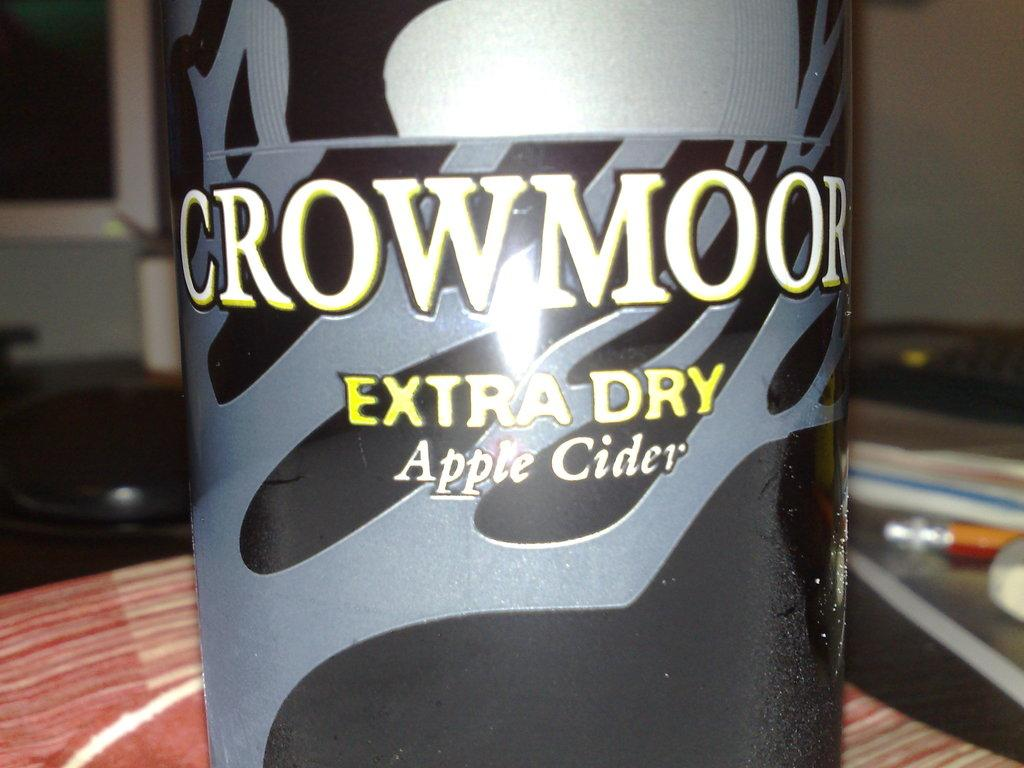<image>
Give a short and clear explanation of the subsequent image. A bottle of Crowmoor Extra Dry Apple Cider is on a desk. 